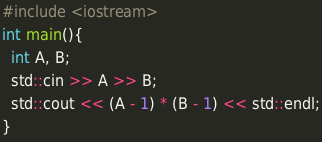Convert code to text. <code><loc_0><loc_0><loc_500><loc_500><_C++_>#include <iostream>
int main(){
  int A, B;
  std::cin >> A >> B;
  std::cout << (A - 1) * (B - 1) << std::endl;
}</code> 